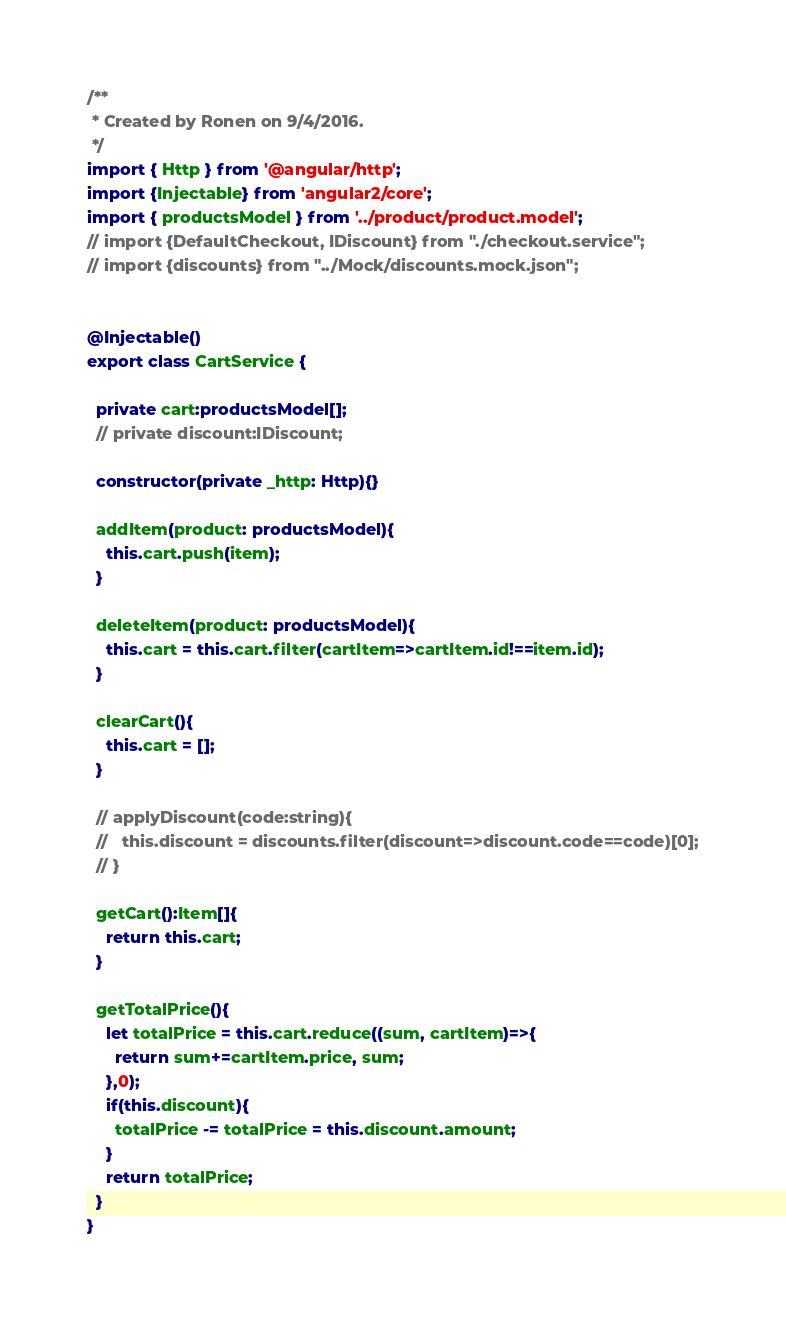<code> <loc_0><loc_0><loc_500><loc_500><_TypeScript_>/**
 * Created by Ronen on 9/4/2016.
 */
import { Http } from '@angular/http';
import {Injectable} from 'angular2/core';
import { productsModel } from '../product/product.model';
// import {DefaultCheckout, IDiscount} from "./checkout.service";
// import {discounts} from "../Mock/discounts.mock.json";


@Injectable()
export class CartService {

  private cart:productsModel[];
  // private discount:IDiscount;

  constructor(private _http: Http){}

  addItem(product: productsModel){
    this.cart.push(item);
  }

  deleteItem(product: productsModel){
    this.cart = this.cart.filter(cartItem=>cartItem.id!==item.id);
  }

  clearCart(){
    this.cart = [];
  }

  // applyDiscount(code:string){
  //   this.discount = discounts.filter(discount=>discount.code==code)[0];
  // }

  getCart():Item[]{
    return this.cart;
  }

  getTotalPrice(){
    let totalPrice = this.cart.reduce((sum, cartItem)=>{
      return sum+=cartItem.price, sum;
    },0);
    if(this.discount){
      totalPrice -= totalPrice = this.discount.amount;
    }
    return totalPrice;
  }
}
</code> 